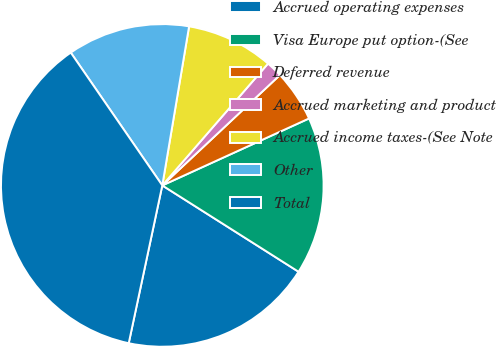Convert chart. <chart><loc_0><loc_0><loc_500><loc_500><pie_chart><fcel>Accrued operating expenses<fcel>Visa Europe put option-(See<fcel>Deferred revenue<fcel>Accrued marketing and product<fcel>Accrued income taxes-(See Note<fcel>Other<fcel>Total<nl><fcel>19.35%<fcel>15.8%<fcel>5.18%<fcel>1.63%<fcel>8.72%<fcel>12.26%<fcel>37.06%<nl></chart> 